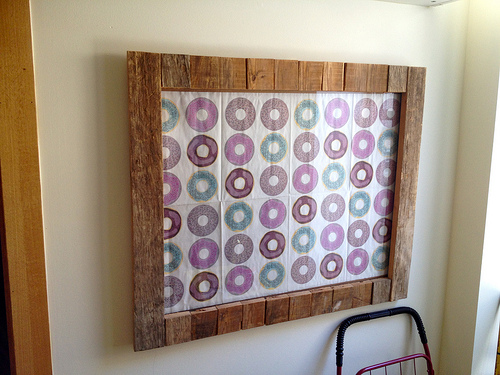<image>
Can you confirm if the cloth is under the wooden frame? Yes. The cloth is positioned underneath the wooden frame, with the wooden frame above it in the vertical space. 